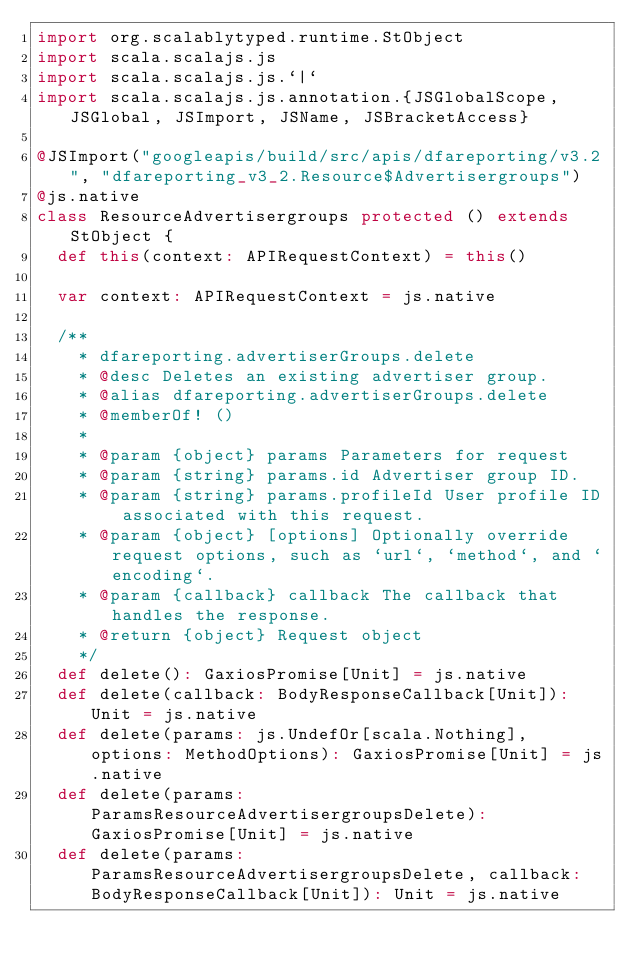<code> <loc_0><loc_0><loc_500><loc_500><_Scala_>import org.scalablytyped.runtime.StObject
import scala.scalajs.js
import scala.scalajs.js.`|`
import scala.scalajs.js.annotation.{JSGlobalScope, JSGlobal, JSImport, JSName, JSBracketAccess}

@JSImport("googleapis/build/src/apis/dfareporting/v3.2", "dfareporting_v3_2.Resource$Advertisergroups")
@js.native
class ResourceAdvertisergroups protected () extends StObject {
  def this(context: APIRequestContext) = this()
  
  var context: APIRequestContext = js.native
  
  /**
    * dfareporting.advertiserGroups.delete
    * @desc Deletes an existing advertiser group.
    * @alias dfareporting.advertiserGroups.delete
    * @memberOf! ()
    *
    * @param {object} params Parameters for request
    * @param {string} params.id Advertiser group ID.
    * @param {string} params.profileId User profile ID associated with this request.
    * @param {object} [options] Optionally override request options, such as `url`, `method`, and `encoding`.
    * @param {callback} callback The callback that handles the response.
    * @return {object} Request object
    */
  def delete(): GaxiosPromise[Unit] = js.native
  def delete(callback: BodyResponseCallback[Unit]): Unit = js.native
  def delete(params: js.UndefOr[scala.Nothing], options: MethodOptions): GaxiosPromise[Unit] = js.native
  def delete(params: ParamsResourceAdvertisergroupsDelete): GaxiosPromise[Unit] = js.native
  def delete(params: ParamsResourceAdvertisergroupsDelete, callback: BodyResponseCallback[Unit]): Unit = js.native</code> 